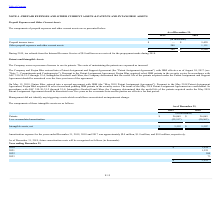According to Finjan Holding's financial document, What is the value of tax refunds from the Internal Revenue Service in 2019? According to the financial document, $5.0 million. The relevant text states: ", tax refunds from the Internal Revenue Service of $5.0 million were received for the prepayment made during 2018...." Also, What are the respective prepaid income taxes in 2019 and 2018? The document shows two values: 0 and 5,429 (in thousands). From the document: "Prepaid income taxes $ — $ 5,429 2019 2018..." Also, What are the respective values of other prepaid expenses and other current assets in 2019 and 2018? The document shows two values: 288 and 1,151 (in thousands). From the document: "her prepaid expenses and other current assets 288 1,151 Other prepaid expenses and other current assets 288 1,151..." Also, can you calculate: What is the average value of total paid expenses and other current assets in 2018 and 2019? To answer this question, I need to perform calculations using the financial data. The calculation is: (288 + 6,580)/2 , which equals 3434 (in thousands). This is based on the information: "$ 288 $ 6,580 Other prepaid expenses and other current assets 288 1,151..." The key data points involved are: 288, 6,580. Also, can you calculate: What is the value of the prepaid income taxes as a percentage of the total prepaid expenses and other current assets in 2018? Based on the calculation: 5,429/6,580 , the result is 82.51 (percentage). This is based on the information: "Prepaid income taxes $ — $ 5,429 $ 288 $ 6,580..." The key data points involved are: 5,429, 6,580. Also, can you calculate: What is the percentage change in other prepaid expenses and other current assets between 2018 and 2019? To answer this question, I need to perform calculations using the financial data. The calculation is: (288 - 1,151)/1,151 , which equals -74.98 (percentage). This is based on the information: "her prepaid expenses and other current assets 288 1,151 Other prepaid expenses and other current assets 288 1,151..." The key data points involved are: 1,151, 288. 